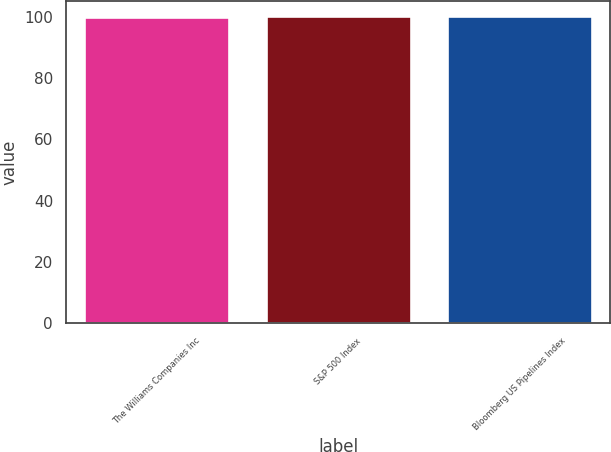<chart> <loc_0><loc_0><loc_500><loc_500><bar_chart><fcel>The Williams Companies Inc<fcel>S&P 500 Index<fcel>Bloomberg US Pipelines Index<nl><fcel>100<fcel>100.1<fcel>100.2<nl></chart> 